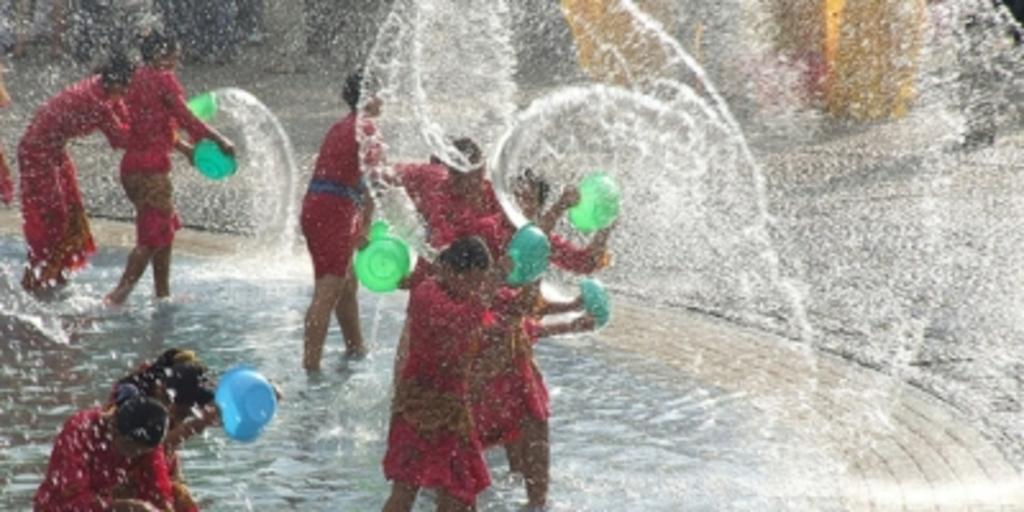Who or what is present in the image? There are people in the image. What are the people doing in the image? The people are standing in the image. What objects are the people holding in their hands? The people are holding bowls in their hands. What is inside the bowls that the people are holding? The bowls contain water. What type of quiver can be seen on the person's back in the image? There is no quiver present on anyone's back in the image. How does the string attached to the bowls affect the people's ability to hold them? There is no string attached to the bowls in the image, so it does not affect the people's ability to hold them. 